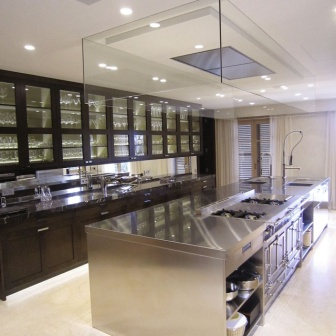What type of cooking activities does this kitchen layout best support? This kitchen layout is particularly suited to both solo and collaborative cooking experiences. The spacious island in the center provides ample room for meal preparation and is ideal for hosting cooking classes or social cooking events. The professional-grade range and broad counter space allow for complex meal preparations and can easily accommodate multiple people working simultaneously without feeling cramped. 